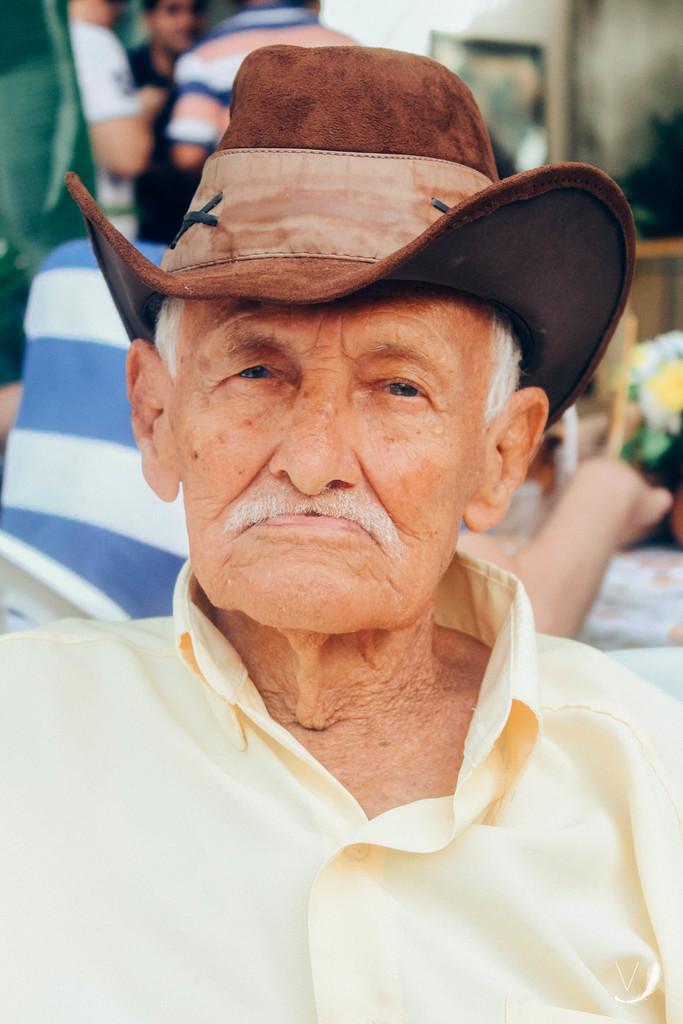In one or two sentences, can you explain what this image depicts? In the center of the image, we can see a person wearing a hat and in the background, there are some other people and we can see some objects. 